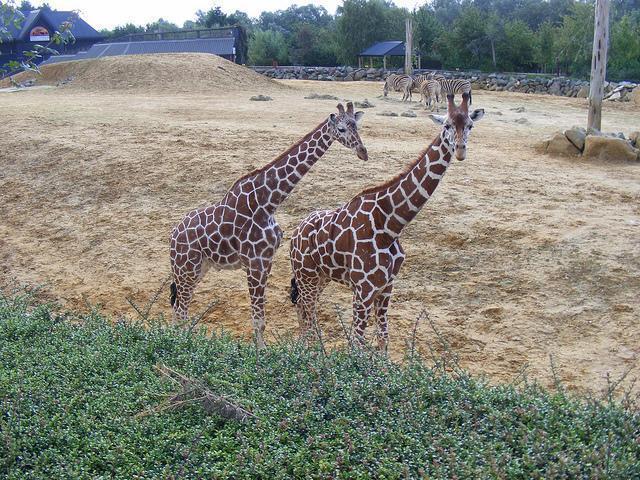How many giraffe in the photo?
Give a very brief answer. 2. How many giraffes are there?
Give a very brief answer. 2. 